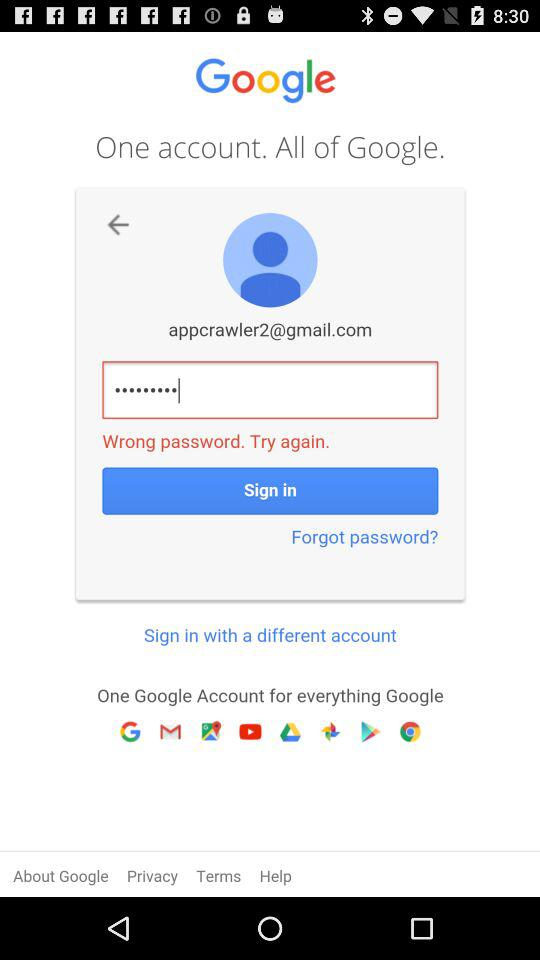What is the email address? The email address is "appcrawler2@gmail.com". 